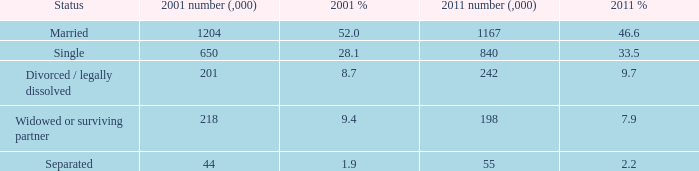What is the 2011 value (,000) when 2001 rate is 2 840.0. 